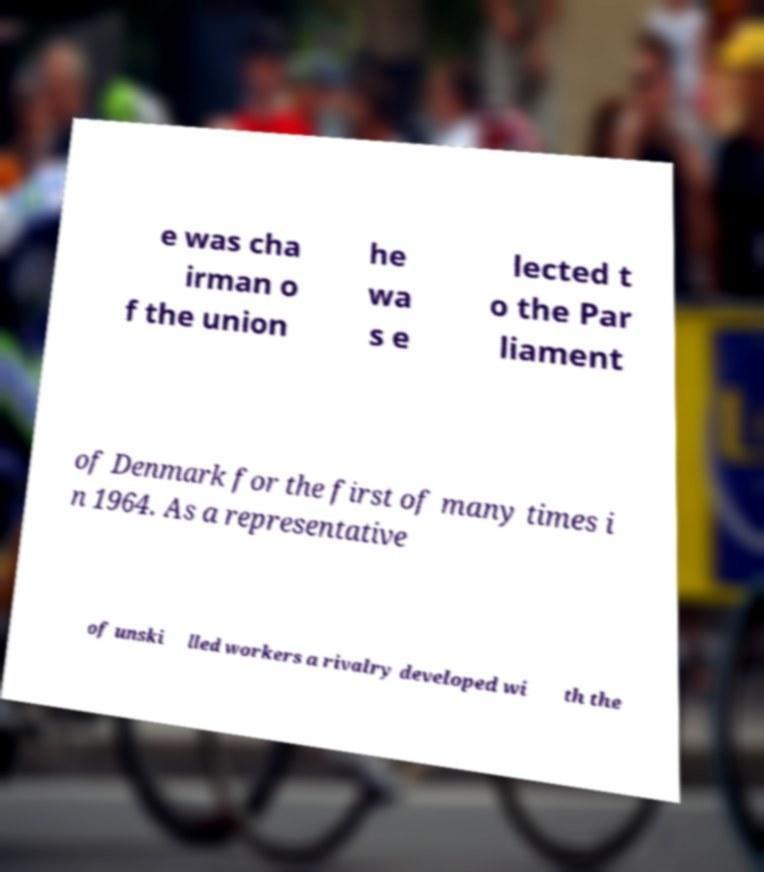For documentation purposes, I need the text within this image transcribed. Could you provide that? e was cha irman o f the union he wa s e lected t o the Par liament of Denmark for the first of many times i n 1964. As a representative of unski lled workers a rivalry developed wi th the 